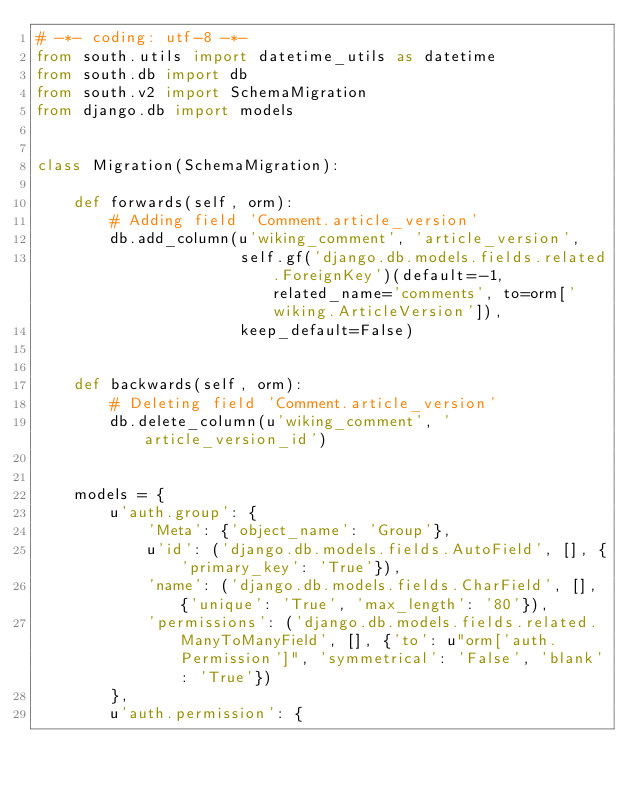Convert code to text. <code><loc_0><loc_0><loc_500><loc_500><_Python_># -*- coding: utf-8 -*-
from south.utils import datetime_utils as datetime
from south.db import db
from south.v2 import SchemaMigration
from django.db import models


class Migration(SchemaMigration):

    def forwards(self, orm):
        # Adding field 'Comment.article_version'
        db.add_column(u'wiking_comment', 'article_version',
                      self.gf('django.db.models.fields.related.ForeignKey')(default=-1, related_name='comments', to=orm['wiking.ArticleVersion']),
                      keep_default=False)


    def backwards(self, orm):
        # Deleting field 'Comment.article_version'
        db.delete_column(u'wiking_comment', 'article_version_id')


    models = {
        u'auth.group': {
            'Meta': {'object_name': 'Group'},
            u'id': ('django.db.models.fields.AutoField', [], {'primary_key': 'True'}),
            'name': ('django.db.models.fields.CharField', [], {'unique': 'True', 'max_length': '80'}),
            'permissions': ('django.db.models.fields.related.ManyToManyField', [], {'to': u"orm['auth.Permission']", 'symmetrical': 'False', 'blank': 'True'})
        },
        u'auth.permission': {</code> 